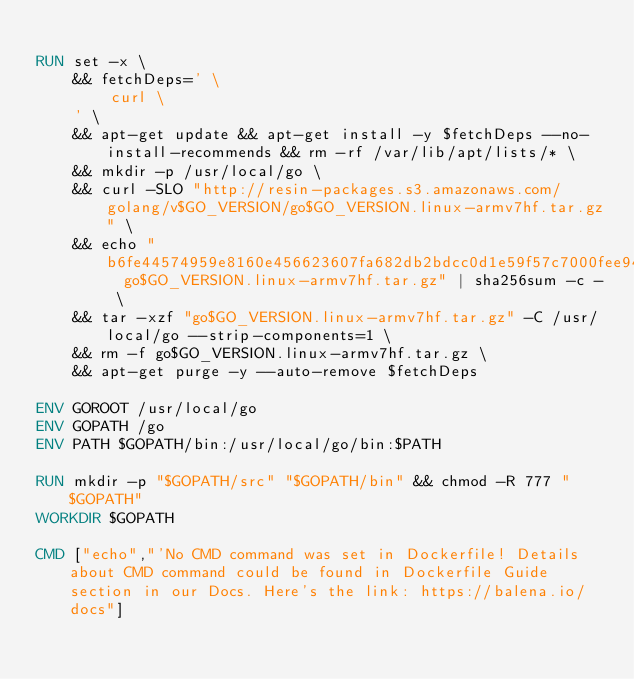<code> <loc_0><loc_0><loc_500><loc_500><_Dockerfile_>
RUN set -x \
	&& fetchDeps=' \
		curl \
	' \
	&& apt-get update && apt-get install -y $fetchDeps --no-install-recommends && rm -rf /var/lib/apt/lists/* \
	&& mkdir -p /usr/local/go \
	&& curl -SLO "http://resin-packages.s3.amazonaws.com/golang/v$GO_VERSION/go$GO_VERSION.linux-armv7hf.tar.gz" \
	&& echo "b6fe44574959e8160e456623607fa682db2bdcc0d1e59f57c7000fee9455f7b5  go$GO_VERSION.linux-armv7hf.tar.gz" | sha256sum -c - \
	&& tar -xzf "go$GO_VERSION.linux-armv7hf.tar.gz" -C /usr/local/go --strip-components=1 \
	&& rm -f go$GO_VERSION.linux-armv7hf.tar.gz \
	&& apt-get purge -y --auto-remove $fetchDeps

ENV GOROOT /usr/local/go
ENV GOPATH /go
ENV PATH $GOPATH/bin:/usr/local/go/bin:$PATH

RUN mkdir -p "$GOPATH/src" "$GOPATH/bin" && chmod -R 777 "$GOPATH"
WORKDIR $GOPATH

CMD ["echo","'No CMD command was set in Dockerfile! Details about CMD command could be found in Dockerfile Guide section in our Docs. Here's the link: https://balena.io/docs"]</code> 